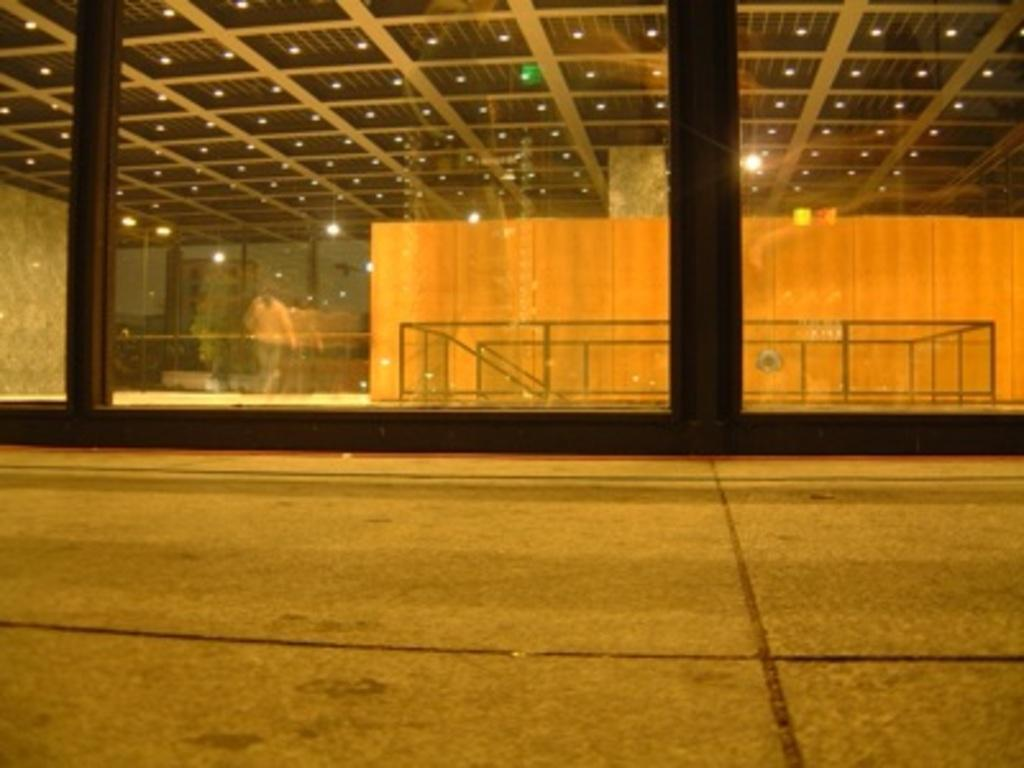What type of structure is present in the image? There is a building in the image. What can be seen illuminated in the image? There are lights visible in the image. What material is used for the construction of the building? Iron rods are present in the image, which suggests they might be part of the building's construction. Can you describe the person in the image? There is a person standing in the image. What is reflected in the image? There is a reflection of another building in the image. What is visible in the background of the image? The sky is visible in the image. What type of coat is the person wearing in the image? There is no coat visible in the image; the person is not wearing any outerwear. What type of glass is used for the windows in the building? The image does not provide enough detail to determine the type of glass used for the windows in the building. 